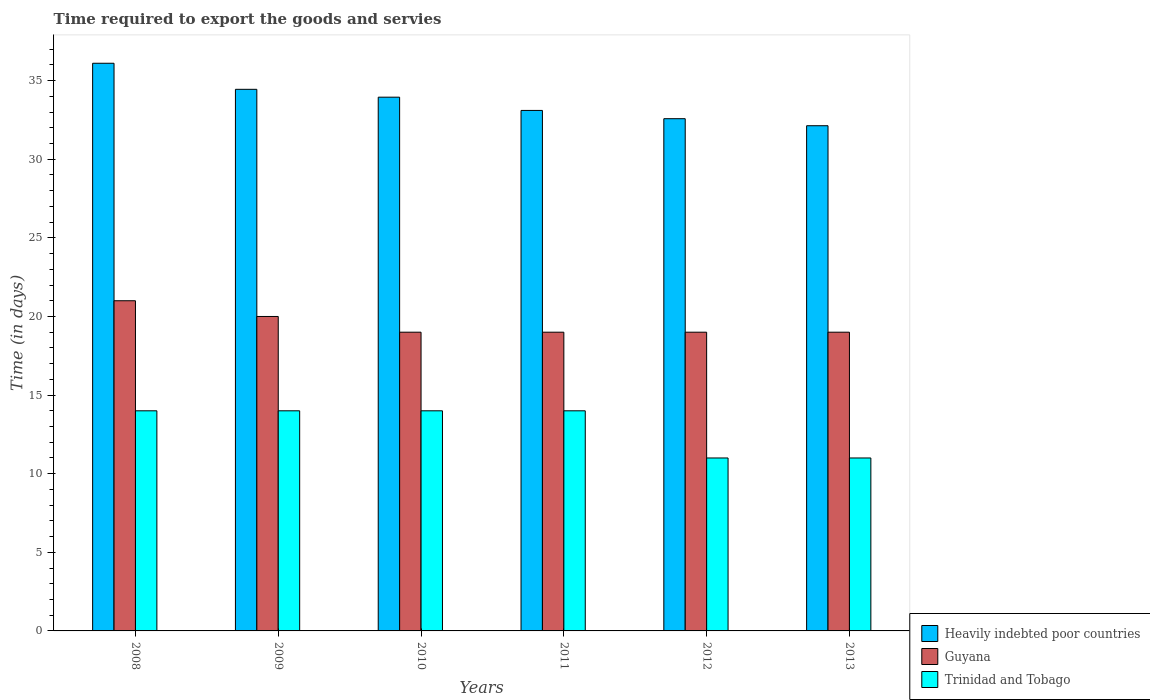Are the number of bars on each tick of the X-axis equal?
Ensure brevity in your answer.  Yes. How many bars are there on the 4th tick from the left?
Your response must be concise. 3. How many bars are there on the 4th tick from the right?
Your answer should be very brief. 3. What is the label of the 1st group of bars from the left?
Keep it short and to the point. 2008. In how many cases, is the number of bars for a given year not equal to the number of legend labels?
Provide a succinct answer. 0. What is the number of days required to export the goods and services in Trinidad and Tobago in 2008?
Provide a short and direct response. 14. Across all years, what is the maximum number of days required to export the goods and services in Heavily indebted poor countries?
Your response must be concise. 36.11. Across all years, what is the minimum number of days required to export the goods and services in Heavily indebted poor countries?
Your answer should be compact. 32.13. What is the total number of days required to export the goods and services in Guyana in the graph?
Your response must be concise. 117. What is the difference between the number of days required to export the goods and services in Guyana in 2009 and that in 2011?
Your answer should be compact. 1. What is the difference between the number of days required to export the goods and services in Heavily indebted poor countries in 2010 and the number of days required to export the goods and services in Guyana in 2012?
Keep it short and to the point. 14.95. In the year 2012, what is the difference between the number of days required to export the goods and services in Trinidad and Tobago and number of days required to export the goods and services in Heavily indebted poor countries?
Your response must be concise. -21.58. In how many years, is the number of days required to export the goods and services in Guyana greater than 30 days?
Your answer should be very brief. 0. What is the ratio of the number of days required to export the goods and services in Heavily indebted poor countries in 2009 to that in 2012?
Give a very brief answer. 1.06. Is the number of days required to export the goods and services in Trinidad and Tobago in 2008 less than that in 2009?
Offer a very short reply. No. What is the difference between the highest and the lowest number of days required to export the goods and services in Guyana?
Your answer should be compact. 2. What does the 1st bar from the left in 2010 represents?
Your answer should be compact. Heavily indebted poor countries. What does the 3rd bar from the right in 2008 represents?
Provide a short and direct response. Heavily indebted poor countries. How many bars are there?
Provide a short and direct response. 18. What is the difference between two consecutive major ticks on the Y-axis?
Provide a short and direct response. 5. Does the graph contain any zero values?
Your response must be concise. No. Does the graph contain grids?
Provide a short and direct response. No. How are the legend labels stacked?
Offer a terse response. Vertical. What is the title of the graph?
Give a very brief answer. Time required to export the goods and servies. Does "Ethiopia" appear as one of the legend labels in the graph?
Your answer should be compact. No. What is the label or title of the X-axis?
Make the answer very short. Years. What is the label or title of the Y-axis?
Provide a succinct answer. Time (in days). What is the Time (in days) of Heavily indebted poor countries in 2008?
Ensure brevity in your answer.  36.11. What is the Time (in days) of Guyana in 2008?
Ensure brevity in your answer.  21. What is the Time (in days) in Trinidad and Tobago in 2008?
Offer a terse response. 14. What is the Time (in days) of Heavily indebted poor countries in 2009?
Make the answer very short. 34.45. What is the Time (in days) of Heavily indebted poor countries in 2010?
Your response must be concise. 33.95. What is the Time (in days) in Heavily indebted poor countries in 2011?
Offer a very short reply. 33.11. What is the Time (in days) in Guyana in 2011?
Keep it short and to the point. 19. What is the Time (in days) in Heavily indebted poor countries in 2012?
Make the answer very short. 32.58. What is the Time (in days) of Heavily indebted poor countries in 2013?
Your answer should be very brief. 32.13. What is the Time (in days) of Guyana in 2013?
Your answer should be very brief. 19. What is the Time (in days) in Trinidad and Tobago in 2013?
Provide a short and direct response. 11. Across all years, what is the maximum Time (in days) in Heavily indebted poor countries?
Your answer should be compact. 36.11. Across all years, what is the maximum Time (in days) in Trinidad and Tobago?
Make the answer very short. 14. Across all years, what is the minimum Time (in days) in Heavily indebted poor countries?
Give a very brief answer. 32.13. Across all years, what is the minimum Time (in days) of Trinidad and Tobago?
Your answer should be very brief. 11. What is the total Time (in days) of Heavily indebted poor countries in the graph?
Ensure brevity in your answer.  202.32. What is the total Time (in days) of Guyana in the graph?
Your answer should be very brief. 117. What is the total Time (in days) of Trinidad and Tobago in the graph?
Keep it short and to the point. 78. What is the difference between the Time (in days) in Heavily indebted poor countries in 2008 and that in 2009?
Provide a short and direct response. 1.66. What is the difference between the Time (in days) in Trinidad and Tobago in 2008 and that in 2009?
Provide a succinct answer. 0. What is the difference between the Time (in days) of Heavily indebted poor countries in 2008 and that in 2010?
Your response must be concise. 2.16. What is the difference between the Time (in days) of Heavily indebted poor countries in 2008 and that in 2012?
Your response must be concise. 3.53. What is the difference between the Time (in days) of Guyana in 2008 and that in 2012?
Your answer should be compact. 2. What is the difference between the Time (in days) of Heavily indebted poor countries in 2008 and that in 2013?
Offer a very short reply. 3.97. What is the difference between the Time (in days) of Guyana in 2008 and that in 2013?
Provide a short and direct response. 2. What is the difference between the Time (in days) of Heavily indebted poor countries in 2009 and that in 2011?
Your response must be concise. 1.34. What is the difference between the Time (in days) in Heavily indebted poor countries in 2009 and that in 2012?
Make the answer very short. 1.87. What is the difference between the Time (in days) of Guyana in 2009 and that in 2012?
Offer a very short reply. 1. What is the difference between the Time (in days) in Heavily indebted poor countries in 2009 and that in 2013?
Provide a short and direct response. 2.32. What is the difference between the Time (in days) in Guyana in 2009 and that in 2013?
Your response must be concise. 1. What is the difference between the Time (in days) of Heavily indebted poor countries in 2010 and that in 2011?
Make the answer very short. 0.84. What is the difference between the Time (in days) of Trinidad and Tobago in 2010 and that in 2011?
Keep it short and to the point. 0. What is the difference between the Time (in days) in Heavily indebted poor countries in 2010 and that in 2012?
Your answer should be compact. 1.37. What is the difference between the Time (in days) of Guyana in 2010 and that in 2012?
Your answer should be very brief. 0. What is the difference between the Time (in days) in Heavily indebted poor countries in 2010 and that in 2013?
Provide a succinct answer. 1.82. What is the difference between the Time (in days) of Trinidad and Tobago in 2010 and that in 2013?
Keep it short and to the point. 3. What is the difference between the Time (in days) in Heavily indebted poor countries in 2011 and that in 2012?
Your response must be concise. 0.53. What is the difference between the Time (in days) in Heavily indebted poor countries in 2011 and that in 2013?
Keep it short and to the point. 0.97. What is the difference between the Time (in days) in Heavily indebted poor countries in 2012 and that in 2013?
Your answer should be very brief. 0.45. What is the difference between the Time (in days) in Trinidad and Tobago in 2012 and that in 2013?
Your answer should be compact. 0. What is the difference between the Time (in days) in Heavily indebted poor countries in 2008 and the Time (in days) in Guyana in 2009?
Provide a succinct answer. 16.11. What is the difference between the Time (in days) of Heavily indebted poor countries in 2008 and the Time (in days) of Trinidad and Tobago in 2009?
Your answer should be very brief. 22.11. What is the difference between the Time (in days) in Heavily indebted poor countries in 2008 and the Time (in days) in Guyana in 2010?
Offer a very short reply. 17.11. What is the difference between the Time (in days) in Heavily indebted poor countries in 2008 and the Time (in days) in Trinidad and Tobago in 2010?
Offer a very short reply. 22.11. What is the difference between the Time (in days) of Guyana in 2008 and the Time (in days) of Trinidad and Tobago in 2010?
Make the answer very short. 7. What is the difference between the Time (in days) of Heavily indebted poor countries in 2008 and the Time (in days) of Guyana in 2011?
Offer a very short reply. 17.11. What is the difference between the Time (in days) in Heavily indebted poor countries in 2008 and the Time (in days) in Trinidad and Tobago in 2011?
Make the answer very short. 22.11. What is the difference between the Time (in days) in Heavily indebted poor countries in 2008 and the Time (in days) in Guyana in 2012?
Offer a very short reply. 17.11. What is the difference between the Time (in days) in Heavily indebted poor countries in 2008 and the Time (in days) in Trinidad and Tobago in 2012?
Provide a short and direct response. 25.11. What is the difference between the Time (in days) of Heavily indebted poor countries in 2008 and the Time (in days) of Guyana in 2013?
Make the answer very short. 17.11. What is the difference between the Time (in days) in Heavily indebted poor countries in 2008 and the Time (in days) in Trinidad and Tobago in 2013?
Make the answer very short. 25.11. What is the difference between the Time (in days) in Guyana in 2008 and the Time (in days) in Trinidad and Tobago in 2013?
Your answer should be compact. 10. What is the difference between the Time (in days) in Heavily indebted poor countries in 2009 and the Time (in days) in Guyana in 2010?
Your answer should be compact. 15.45. What is the difference between the Time (in days) in Heavily indebted poor countries in 2009 and the Time (in days) in Trinidad and Tobago in 2010?
Your answer should be very brief. 20.45. What is the difference between the Time (in days) in Heavily indebted poor countries in 2009 and the Time (in days) in Guyana in 2011?
Ensure brevity in your answer.  15.45. What is the difference between the Time (in days) in Heavily indebted poor countries in 2009 and the Time (in days) in Trinidad and Tobago in 2011?
Ensure brevity in your answer.  20.45. What is the difference between the Time (in days) of Heavily indebted poor countries in 2009 and the Time (in days) of Guyana in 2012?
Offer a terse response. 15.45. What is the difference between the Time (in days) in Heavily indebted poor countries in 2009 and the Time (in days) in Trinidad and Tobago in 2012?
Provide a succinct answer. 23.45. What is the difference between the Time (in days) in Heavily indebted poor countries in 2009 and the Time (in days) in Guyana in 2013?
Provide a succinct answer. 15.45. What is the difference between the Time (in days) of Heavily indebted poor countries in 2009 and the Time (in days) of Trinidad and Tobago in 2013?
Make the answer very short. 23.45. What is the difference between the Time (in days) in Guyana in 2009 and the Time (in days) in Trinidad and Tobago in 2013?
Ensure brevity in your answer.  9. What is the difference between the Time (in days) in Heavily indebted poor countries in 2010 and the Time (in days) in Guyana in 2011?
Provide a short and direct response. 14.95. What is the difference between the Time (in days) in Heavily indebted poor countries in 2010 and the Time (in days) in Trinidad and Tobago in 2011?
Your answer should be compact. 19.95. What is the difference between the Time (in days) in Guyana in 2010 and the Time (in days) in Trinidad and Tobago in 2011?
Offer a terse response. 5. What is the difference between the Time (in days) of Heavily indebted poor countries in 2010 and the Time (in days) of Guyana in 2012?
Your answer should be very brief. 14.95. What is the difference between the Time (in days) of Heavily indebted poor countries in 2010 and the Time (in days) of Trinidad and Tobago in 2012?
Your response must be concise. 22.95. What is the difference between the Time (in days) of Heavily indebted poor countries in 2010 and the Time (in days) of Guyana in 2013?
Offer a very short reply. 14.95. What is the difference between the Time (in days) of Heavily indebted poor countries in 2010 and the Time (in days) of Trinidad and Tobago in 2013?
Provide a succinct answer. 22.95. What is the difference between the Time (in days) of Heavily indebted poor countries in 2011 and the Time (in days) of Guyana in 2012?
Your answer should be very brief. 14.11. What is the difference between the Time (in days) in Heavily indebted poor countries in 2011 and the Time (in days) in Trinidad and Tobago in 2012?
Provide a short and direct response. 22.11. What is the difference between the Time (in days) in Heavily indebted poor countries in 2011 and the Time (in days) in Guyana in 2013?
Provide a short and direct response. 14.11. What is the difference between the Time (in days) of Heavily indebted poor countries in 2011 and the Time (in days) of Trinidad and Tobago in 2013?
Give a very brief answer. 22.11. What is the difference between the Time (in days) of Guyana in 2011 and the Time (in days) of Trinidad and Tobago in 2013?
Keep it short and to the point. 8. What is the difference between the Time (in days) of Heavily indebted poor countries in 2012 and the Time (in days) of Guyana in 2013?
Provide a short and direct response. 13.58. What is the difference between the Time (in days) in Heavily indebted poor countries in 2012 and the Time (in days) in Trinidad and Tobago in 2013?
Offer a very short reply. 21.58. What is the average Time (in days) in Heavily indebted poor countries per year?
Provide a short and direct response. 33.72. What is the average Time (in days) in Guyana per year?
Ensure brevity in your answer.  19.5. What is the average Time (in days) of Trinidad and Tobago per year?
Ensure brevity in your answer.  13. In the year 2008, what is the difference between the Time (in days) in Heavily indebted poor countries and Time (in days) in Guyana?
Offer a terse response. 15.11. In the year 2008, what is the difference between the Time (in days) in Heavily indebted poor countries and Time (in days) in Trinidad and Tobago?
Keep it short and to the point. 22.11. In the year 2009, what is the difference between the Time (in days) in Heavily indebted poor countries and Time (in days) in Guyana?
Make the answer very short. 14.45. In the year 2009, what is the difference between the Time (in days) in Heavily indebted poor countries and Time (in days) in Trinidad and Tobago?
Keep it short and to the point. 20.45. In the year 2009, what is the difference between the Time (in days) in Guyana and Time (in days) in Trinidad and Tobago?
Your response must be concise. 6. In the year 2010, what is the difference between the Time (in days) in Heavily indebted poor countries and Time (in days) in Guyana?
Provide a short and direct response. 14.95. In the year 2010, what is the difference between the Time (in days) in Heavily indebted poor countries and Time (in days) in Trinidad and Tobago?
Make the answer very short. 19.95. In the year 2011, what is the difference between the Time (in days) of Heavily indebted poor countries and Time (in days) of Guyana?
Give a very brief answer. 14.11. In the year 2011, what is the difference between the Time (in days) in Heavily indebted poor countries and Time (in days) in Trinidad and Tobago?
Your response must be concise. 19.11. In the year 2011, what is the difference between the Time (in days) in Guyana and Time (in days) in Trinidad and Tobago?
Provide a succinct answer. 5. In the year 2012, what is the difference between the Time (in days) in Heavily indebted poor countries and Time (in days) in Guyana?
Keep it short and to the point. 13.58. In the year 2012, what is the difference between the Time (in days) of Heavily indebted poor countries and Time (in days) of Trinidad and Tobago?
Offer a very short reply. 21.58. In the year 2013, what is the difference between the Time (in days) in Heavily indebted poor countries and Time (in days) in Guyana?
Provide a short and direct response. 13.13. In the year 2013, what is the difference between the Time (in days) of Heavily indebted poor countries and Time (in days) of Trinidad and Tobago?
Provide a succinct answer. 21.13. In the year 2013, what is the difference between the Time (in days) of Guyana and Time (in days) of Trinidad and Tobago?
Keep it short and to the point. 8. What is the ratio of the Time (in days) of Heavily indebted poor countries in 2008 to that in 2009?
Your answer should be very brief. 1.05. What is the ratio of the Time (in days) of Trinidad and Tobago in 2008 to that in 2009?
Give a very brief answer. 1. What is the ratio of the Time (in days) of Heavily indebted poor countries in 2008 to that in 2010?
Ensure brevity in your answer.  1.06. What is the ratio of the Time (in days) of Guyana in 2008 to that in 2010?
Your answer should be compact. 1.11. What is the ratio of the Time (in days) of Heavily indebted poor countries in 2008 to that in 2011?
Keep it short and to the point. 1.09. What is the ratio of the Time (in days) in Guyana in 2008 to that in 2011?
Keep it short and to the point. 1.11. What is the ratio of the Time (in days) in Trinidad and Tobago in 2008 to that in 2011?
Your answer should be compact. 1. What is the ratio of the Time (in days) in Heavily indebted poor countries in 2008 to that in 2012?
Make the answer very short. 1.11. What is the ratio of the Time (in days) in Guyana in 2008 to that in 2012?
Your answer should be very brief. 1.11. What is the ratio of the Time (in days) in Trinidad and Tobago in 2008 to that in 2012?
Your response must be concise. 1.27. What is the ratio of the Time (in days) in Heavily indebted poor countries in 2008 to that in 2013?
Your response must be concise. 1.12. What is the ratio of the Time (in days) in Guyana in 2008 to that in 2013?
Ensure brevity in your answer.  1.11. What is the ratio of the Time (in days) in Trinidad and Tobago in 2008 to that in 2013?
Your answer should be compact. 1.27. What is the ratio of the Time (in days) in Heavily indebted poor countries in 2009 to that in 2010?
Provide a succinct answer. 1.01. What is the ratio of the Time (in days) in Guyana in 2009 to that in 2010?
Your answer should be very brief. 1.05. What is the ratio of the Time (in days) in Heavily indebted poor countries in 2009 to that in 2011?
Ensure brevity in your answer.  1.04. What is the ratio of the Time (in days) in Guyana in 2009 to that in 2011?
Make the answer very short. 1.05. What is the ratio of the Time (in days) of Heavily indebted poor countries in 2009 to that in 2012?
Your answer should be very brief. 1.06. What is the ratio of the Time (in days) of Guyana in 2009 to that in 2012?
Ensure brevity in your answer.  1.05. What is the ratio of the Time (in days) of Trinidad and Tobago in 2009 to that in 2012?
Keep it short and to the point. 1.27. What is the ratio of the Time (in days) of Heavily indebted poor countries in 2009 to that in 2013?
Provide a short and direct response. 1.07. What is the ratio of the Time (in days) in Guyana in 2009 to that in 2013?
Provide a succinct answer. 1.05. What is the ratio of the Time (in days) in Trinidad and Tobago in 2009 to that in 2013?
Offer a terse response. 1.27. What is the ratio of the Time (in days) in Heavily indebted poor countries in 2010 to that in 2011?
Provide a short and direct response. 1.03. What is the ratio of the Time (in days) of Heavily indebted poor countries in 2010 to that in 2012?
Your response must be concise. 1.04. What is the ratio of the Time (in days) in Guyana in 2010 to that in 2012?
Make the answer very short. 1. What is the ratio of the Time (in days) in Trinidad and Tobago in 2010 to that in 2012?
Ensure brevity in your answer.  1.27. What is the ratio of the Time (in days) in Heavily indebted poor countries in 2010 to that in 2013?
Offer a terse response. 1.06. What is the ratio of the Time (in days) of Guyana in 2010 to that in 2013?
Your answer should be very brief. 1. What is the ratio of the Time (in days) in Trinidad and Tobago in 2010 to that in 2013?
Keep it short and to the point. 1.27. What is the ratio of the Time (in days) in Heavily indebted poor countries in 2011 to that in 2012?
Provide a succinct answer. 1.02. What is the ratio of the Time (in days) in Guyana in 2011 to that in 2012?
Give a very brief answer. 1. What is the ratio of the Time (in days) of Trinidad and Tobago in 2011 to that in 2012?
Offer a very short reply. 1.27. What is the ratio of the Time (in days) in Heavily indebted poor countries in 2011 to that in 2013?
Your answer should be very brief. 1.03. What is the ratio of the Time (in days) of Guyana in 2011 to that in 2013?
Give a very brief answer. 1. What is the ratio of the Time (in days) of Trinidad and Tobago in 2011 to that in 2013?
Provide a short and direct response. 1.27. What is the ratio of the Time (in days) in Heavily indebted poor countries in 2012 to that in 2013?
Ensure brevity in your answer.  1.01. What is the ratio of the Time (in days) in Trinidad and Tobago in 2012 to that in 2013?
Offer a very short reply. 1. What is the difference between the highest and the second highest Time (in days) of Heavily indebted poor countries?
Your response must be concise. 1.66. What is the difference between the highest and the second highest Time (in days) in Guyana?
Offer a terse response. 1. What is the difference between the highest and the second highest Time (in days) of Trinidad and Tobago?
Provide a short and direct response. 0. What is the difference between the highest and the lowest Time (in days) in Heavily indebted poor countries?
Give a very brief answer. 3.97. What is the difference between the highest and the lowest Time (in days) in Trinidad and Tobago?
Your answer should be very brief. 3. 